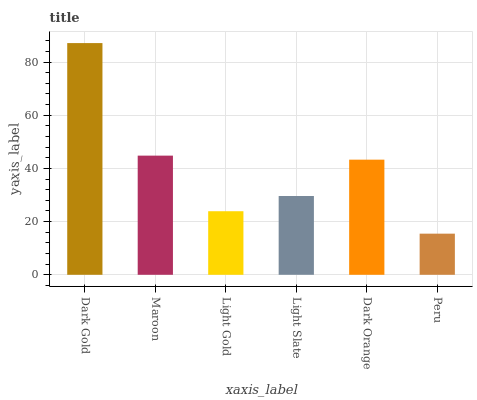Is Peru the minimum?
Answer yes or no. Yes. Is Dark Gold the maximum?
Answer yes or no. Yes. Is Maroon the minimum?
Answer yes or no. No. Is Maroon the maximum?
Answer yes or no. No. Is Dark Gold greater than Maroon?
Answer yes or no. Yes. Is Maroon less than Dark Gold?
Answer yes or no. Yes. Is Maroon greater than Dark Gold?
Answer yes or no. No. Is Dark Gold less than Maroon?
Answer yes or no. No. Is Dark Orange the high median?
Answer yes or no. Yes. Is Light Slate the low median?
Answer yes or no. Yes. Is Maroon the high median?
Answer yes or no. No. Is Maroon the low median?
Answer yes or no. No. 